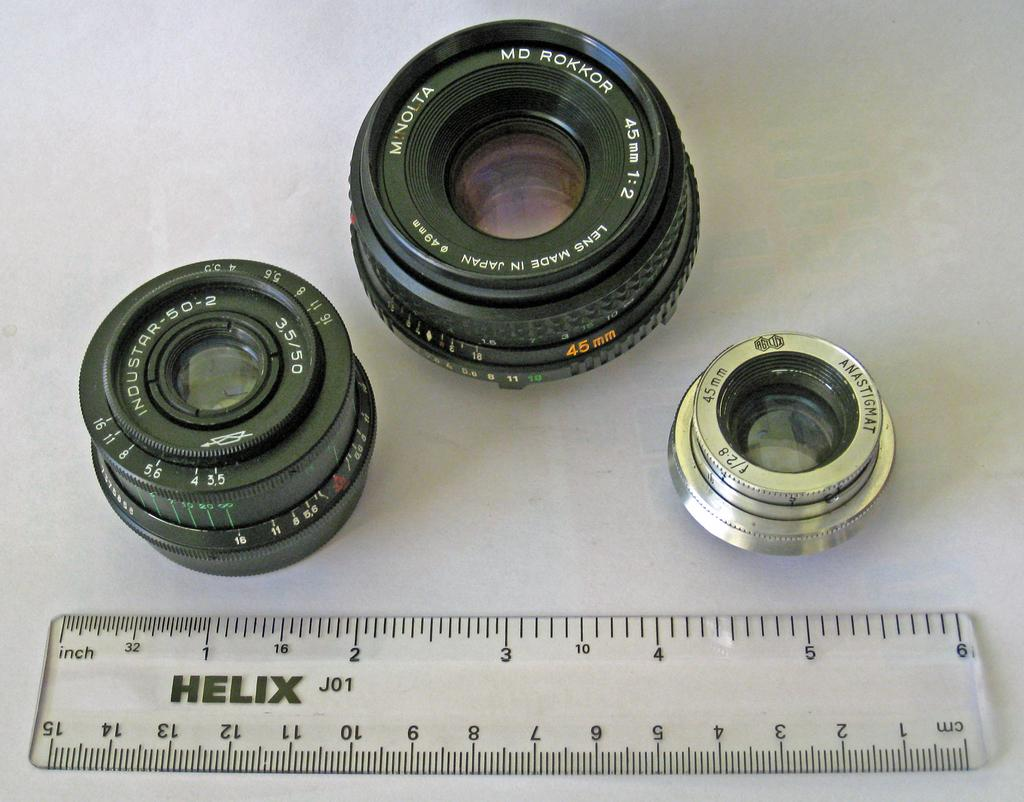<image>
Describe the image concisely. Three camera lenses in front of a clear Helix brand ruler. 